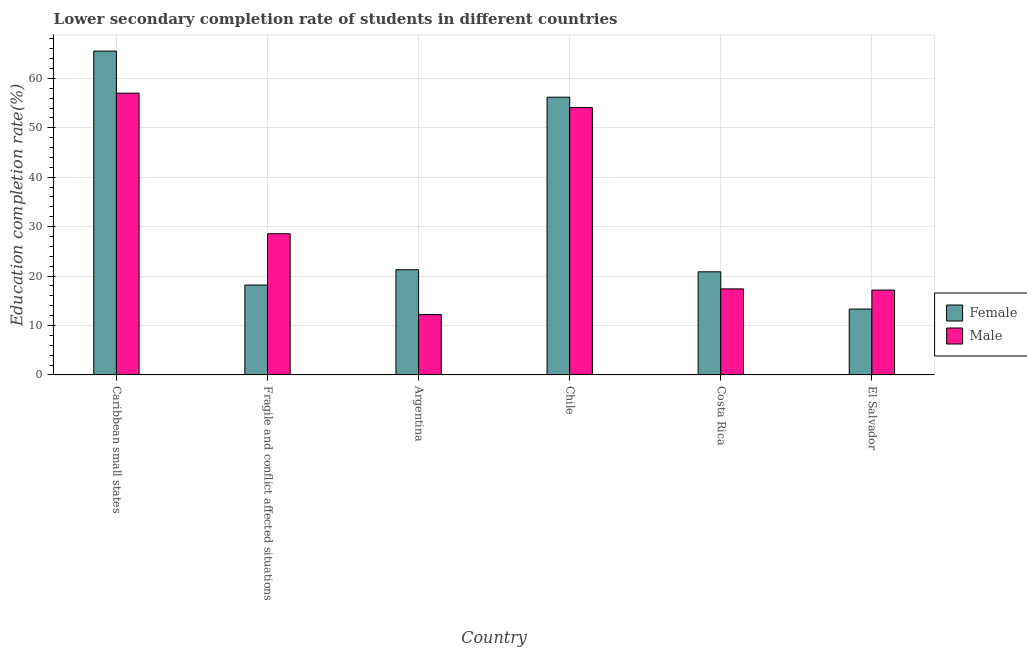How many different coloured bars are there?
Offer a very short reply. 2. Are the number of bars per tick equal to the number of legend labels?
Offer a very short reply. Yes. Are the number of bars on each tick of the X-axis equal?
Give a very brief answer. Yes. What is the label of the 6th group of bars from the left?
Offer a very short reply. El Salvador. In how many cases, is the number of bars for a given country not equal to the number of legend labels?
Offer a very short reply. 0. What is the education completion rate of female students in Argentina?
Ensure brevity in your answer.  21.28. Across all countries, what is the maximum education completion rate of male students?
Your response must be concise. 57. Across all countries, what is the minimum education completion rate of female students?
Make the answer very short. 13.32. In which country was the education completion rate of female students maximum?
Give a very brief answer. Caribbean small states. In which country was the education completion rate of male students minimum?
Your response must be concise. Argentina. What is the total education completion rate of female students in the graph?
Ensure brevity in your answer.  195.36. What is the difference between the education completion rate of female students in Argentina and that in Chile?
Your response must be concise. -34.91. What is the difference between the education completion rate of female students in Argentina and the education completion rate of male students in Caribbean small states?
Give a very brief answer. -35.72. What is the average education completion rate of male students per country?
Provide a succinct answer. 31.07. What is the difference between the education completion rate of female students and education completion rate of male students in Fragile and conflict affected situations?
Offer a very short reply. -10.38. In how many countries, is the education completion rate of male students greater than 58 %?
Make the answer very short. 0. What is the ratio of the education completion rate of female students in Chile to that in Costa Rica?
Ensure brevity in your answer.  2.69. What is the difference between the highest and the second highest education completion rate of male students?
Provide a succinct answer. 2.91. What is the difference between the highest and the lowest education completion rate of male students?
Your answer should be compact. 44.79. In how many countries, is the education completion rate of female students greater than the average education completion rate of female students taken over all countries?
Keep it short and to the point. 2. What does the 1st bar from the left in Chile represents?
Your answer should be compact. Female. How many bars are there?
Make the answer very short. 12. Does the graph contain grids?
Give a very brief answer. Yes. Where does the legend appear in the graph?
Give a very brief answer. Center right. How many legend labels are there?
Make the answer very short. 2. What is the title of the graph?
Offer a very short reply. Lower secondary completion rate of students in different countries. What is the label or title of the Y-axis?
Your answer should be very brief. Education completion rate(%). What is the Education completion rate(%) in Female in Caribbean small states?
Your answer should be compact. 65.52. What is the Education completion rate(%) of Male in Caribbean small states?
Keep it short and to the point. 57. What is the Education completion rate(%) of Female in Fragile and conflict affected situations?
Your answer should be compact. 18.18. What is the Education completion rate(%) in Male in Fragile and conflict affected situations?
Your response must be concise. 28.56. What is the Education completion rate(%) of Female in Argentina?
Provide a short and direct response. 21.28. What is the Education completion rate(%) in Male in Argentina?
Your answer should be very brief. 12.21. What is the Education completion rate(%) in Female in Chile?
Your answer should be very brief. 56.19. What is the Education completion rate(%) of Male in Chile?
Your answer should be compact. 54.09. What is the Education completion rate(%) in Female in Costa Rica?
Keep it short and to the point. 20.86. What is the Education completion rate(%) of Male in Costa Rica?
Keep it short and to the point. 17.41. What is the Education completion rate(%) of Female in El Salvador?
Keep it short and to the point. 13.32. What is the Education completion rate(%) of Male in El Salvador?
Make the answer very short. 17.16. Across all countries, what is the maximum Education completion rate(%) in Female?
Give a very brief answer. 65.52. Across all countries, what is the maximum Education completion rate(%) of Male?
Provide a short and direct response. 57. Across all countries, what is the minimum Education completion rate(%) of Female?
Your answer should be very brief. 13.32. Across all countries, what is the minimum Education completion rate(%) of Male?
Your response must be concise. 12.21. What is the total Education completion rate(%) of Female in the graph?
Ensure brevity in your answer.  195.36. What is the total Education completion rate(%) in Male in the graph?
Your response must be concise. 186.43. What is the difference between the Education completion rate(%) in Female in Caribbean small states and that in Fragile and conflict affected situations?
Your answer should be compact. 47.34. What is the difference between the Education completion rate(%) of Male in Caribbean small states and that in Fragile and conflict affected situations?
Your answer should be compact. 28.44. What is the difference between the Education completion rate(%) in Female in Caribbean small states and that in Argentina?
Your answer should be very brief. 44.24. What is the difference between the Education completion rate(%) in Male in Caribbean small states and that in Argentina?
Your answer should be very brief. 44.79. What is the difference between the Education completion rate(%) of Female in Caribbean small states and that in Chile?
Make the answer very short. 9.33. What is the difference between the Education completion rate(%) in Male in Caribbean small states and that in Chile?
Provide a short and direct response. 2.91. What is the difference between the Education completion rate(%) in Female in Caribbean small states and that in Costa Rica?
Provide a short and direct response. 44.66. What is the difference between the Education completion rate(%) in Male in Caribbean small states and that in Costa Rica?
Your answer should be compact. 39.59. What is the difference between the Education completion rate(%) of Female in Caribbean small states and that in El Salvador?
Offer a very short reply. 52.2. What is the difference between the Education completion rate(%) of Male in Caribbean small states and that in El Salvador?
Your response must be concise. 39.84. What is the difference between the Education completion rate(%) in Female in Fragile and conflict affected situations and that in Argentina?
Provide a short and direct response. -3.1. What is the difference between the Education completion rate(%) in Male in Fragile and conflict affected situations and that in Argentina?
Give a very brief answer. 16.35. What is the difference between the Education completion rate(%) of Female in Fragile and conflict affected situations and that in Chile?
Offer a very short reply. -38.01. What is the difference between the Education completion rate(%) in Male in Fragile and conflict affected situations and that in Chile?
Keep it short and to the point. -25.52. What is the difference between the Education completion rate(%) in Female in Fragile and conflict affected situations and that in Costa Rica?
Your answer should be compact. -2.68. What is the difference between the Education completion rate(%) in Male in Fragile and conflict affected situations and that in Costa Rica?
Your answer should be compact. 11.16. What is the difference between the Education completion rate(%) of Female in Fragile and conflict affected situations and that in El Salvador?
Your answer should be compact. 4.86. What is the difference between the Education completion rate(%) in Male in Fragile and conflict affected situations and that in El Salvador?
Offer a terse response. 11.4. What is the difference between the Education completion rate(%) of Female in Argentina and that in Chile?
Offer a very short reply. -34.91. What is the difference between the Education completion rate(%) of Male in Argentina and that in Chile?
Provide a short and direct response. -41.87. What is the difference between the Education completion rate(%) of Female in Argentina and that in Costa Rica?
Give a very brief answer. 0.42. What is the difference between the Education completion rate(%) in Male in Argentina and that in Costa Rica?
Your answer should be compact. -5.19. What is the difference between the Education completion rate(%) of Female in Argentina and that in El Salvador?
Offer a terse response. 7.95. What is the difference between the Education completion rate(%) in Male in Argentina and that in El Salvador?
Offer a very short reply. -4.95. What is the difference between the Education completion rate(%) of Female in Chile and that in Costa Rica?
Keep it short and to the point. 35.33. What is the difference between the Education completion rate(%) of Male in Chile and that in Costa Rica?
Ensure brevity in your answer.  36.68. What is the difference between the Education completion rate(%) in Female in Chile and that in El Salvador?
Offer a very short reply. 42.87. What is the difference between the Education completion rate(%) in Male in Chile and that in El Salvador?
Give a very brief answer. 36.93. What is the difference between the Education completion rate(%) of Female in Costa Rica and that in El Salvador?
Ensure brevity in your answer.  7.54. What is the difference between the Education completion rate(%) of Male in Costa Rica and that in El Salvador?
Make the answer very short. 0.24. What is the difference between the Education completion rate(%) in Female in Caribbean small states and the Education completion rate(%) in Male in Fragile and conflict affected situations?
Your response must be concise. 36.96. What is the difference between the Education completion rate(%) in Female in Caribbean small states and the Education completion rate(%) in Male in Argentina?
Keep it short and to the point. 53.31. What is the difference between the Education completion rate(%) in Female in Caribbean small states and the Education completion rate(%) in Male in Chile?
Offer a very short reply. 11.43. What is the difference between the Education completion rate(%) of Female in Caribbean small states and the Education completion rate(%) of Male in Costa Rica?
Your answer should be compact. 48.12. What is the difference between the Education completion rate(%) in Female in Caribbean small states and the Education completion rate(%) in Male in El Salvador?
Keep it short and to the point. 48.36. What is the difference between the Education completion rate(%) of Female in Fragile and conflict affected situations and the Education completion rate(%) of Male in Argentina?
Offer a very short reply. 5.97. What is the difference between the Education completion rate(%) of Female in Fragile and conflict affected situations and the Education completion rate(%) of Male in Chile?
Provide a succinct answer. -35.91. What is the difference between the Education completion rate(%) in Female in Fragile and conflict affected situations and the Education completion rate(%) in Male in Costa Rica?
Give a very brief answer. 0.77. What is the difference between the Education completion rate(%) in Female in Fragile and conflict affected situations and the Education completion rate(%) in Male in El Salvador?
Keep it short and to the point. 1.02. What is the difference between the Education completion rate(%) in Female in Argentina and the Education completion rate(%) in Male in Chile?
Give a very brief answer. -32.81. What is the difference between the Education completion rate(%) of Female in Argentina and the Education completion rate(%) of Male in Costa Rica?
Provide a succinct answer. 3.87. What is the difference between the Education completion rate(%) of Female in Argentina and the Education completion rate(%) of Male in El Salvador?
Offer a very short reply. 4.12. What is the difference between the Education completion rate(%) in Female in Chile and the Education completion rate(%) in Male in Costa Rica?
Give a very brief answer. 38.79. What is the difference between the Education completion rate(%) in Female in Chile and the Education completion rate(%) in Male in El Salvador?
Give a very brief answer. 39.03. What is the difference between the Education completion rate(%) in Female in Costa Rica and the Education completion rate(%) in Male in El Salvador?
Your response must be concise. 3.7. What is the average Education completion rate(%) of Female per country?
Your response must be concise. 32.56. What is the average Education completion rate(%) of Male per country?
Ensure brevity in your answer.  31.07. What is the difference between the Education completion rate(%) of Female and Education completion rate(%) of Male in Caribbean small states?
Make the answer very short. 8.52. What is the difference between the Education completion rate(%) in Female and Education completion rate(%) in Male in Fragile and conflict affected situations?
Provide a succinct answer. -10.38. What is the difference between the Education completion rate(%) in Female and Education completion rate(%) in Male in Argentina?
Your response must be concise. 9.07. What is the difference between the Education completion rate(%) of Female and Education completion rate(%) of Male in Chile?
Your response must be concise. 2.1. What is the difference between the Education completion rate(%) in Female and Education completion rate(%) in Male in Costa Rica?
Ensure brevity in your answer.  3.46. What is the difference between the Education completion rate(%) of Female and Education completion rate(%) of Male in El Salvador?
Your answer should be very brief. -3.84. What is the ratio of the Education completion rate(%) in Female in Caribbean small states to that in Fragile and conflict affected situations?
Ensure brevity in your answer.  3.6. What is the ratio of the Education completion rate(%) in Male in Caribbean small states to that in Fragile and conflict affected situations?
Provide a short and direct response. 2. What is the ratio of the Education completion rate(%) in Female in Caribbean small states to that in Argentina?
Your answer should be very brief. 3.08. What is the ratio of the Education completion rate(%) of Male in Caribbean small states to that in Argentina?
Provide a succinct answer. 4.67. What is the ratio of the Education completion rate(%) of Female in Caribbean small states to that in Chile?
Ensure brevity in your answer.  1.17. What is the ratio of the Education completion rate(%) in Male in Caribbean small states to that in Chile?
Offer a very short reply. 1.05. What is the ratio of the Education completion rate(%) of Female in Caribbean small states to that in Costa Rica?
Your response must be concise. 3.14. What is the ratio of the Education completion rate(%) of Male in Caribbean small states to that in Costa Rica?
Make the answer very short. 3.27. What is the ratio of the Education completion rate(%) in Female in Caribbean small states to that in El Salvador?
Provide a succinct answer. 4.92. What is the ratio of the Education completion rate(%) in Male in Caribbean small states to that in El Salvador?
Your answer should be compact. 3.32. What is the ratio of the Education completion rate(%) in Female in Fragile and conflict affected situations to that in Argentina?
Provide a short and direct response. 0.85. What is the ratio of the Education completion rate(%) in Male in Fragile and conflict affected situations to that in Argentina?
Give a very brief answer. 2.34. What is the ratio of the Education completion rate(%) in Female in Fragile and conflict affected situations to that in Chile?
Provide a succinct answer. 0.32. What is the ratio of the Education completion rate(%) in Male in Fragile and conflict affected situations to that in Chile?
Your answer should be very brief. 0.53. What is the ratio of the Education completion rate(%) of Female in Fragile and conflict affected situations to that in Costa Rica?
Provide a short and direct response. 0.87. What is the ratio of the Education completion rate(%) of Male in Fragile and conflict affected situations to that in Costa Rica?
Make the answer very short. 1.64. What is the ratio of the Education completion rate(%) of Female in Fragile and conflict affected situations to that in El Salvador?
Ensure brevity in your answer.  1.36. What is the ratio of the Education completion rate(%) of Male in Fragile and conflict affected situations to that in El Salvador?
Provide a short and direct response. 1.66. What is the ratio of the Education completion rate(%) in Female in Argentina to that in Chile?
Give a very brief answer. 0.38. What is the ratio of the Education completion rate(%) of Male in Argentina to that in Chile?
Make the answer very short. 0.23. What is the ratio of the Education completion rate(%) of Female in Argentina to that in Costa Rica?
Ensure brevity in your answer.  1.02. What is the ratio of the Education completion rate(%) of Male in Argentina to that in Costa Rica?
Your answer should be very brief. 0.7. What is the ratio of the Education completion rate(%) in Female in Argentina to that in El Salvador?
Your response must be concise. 1.6. What is the ratio of the Education completion rate(%) in Male in Argentina to that in El Salvador?
Keep it short and to the point. 0.71. What is the ratio of the Education completion rate(%) in Female in Chile to that in Costa Rica?
Offer a terse response. 2.69. What is the ratio of the Education completion rate(%) in Male in Chile to that in Costa Rica?
Provide a short and direct response. 3.11. What is the ratio of the Education completion rate(%) in Female in Chile to that in El Salvador?
Offer a very short reply. 4.22. What is the ratio of the Education completion rate(%) of Male in Chile to that in El Salvador?
Provide a succinct answer. 3.15. What is the ratio of the Education completion rate(%) in Female in Costa Rica to that in El Salvador?
Your answer should be compact. 1.57. What is the ratio of the Education completion rate(%) in Male in Costa Rica to that in El Salvador?
Give a very brief answer. 1.01. What is the difference between the highest and the second highest Education completion rate(%) in Female?
Ensure brevity in your answer.  9.33. What is the difference between the highest and the second highest Education completion rate(%) in Male?
Offer a very short reply. 2.91. What is the difference between the highest and the lowest Education completion rate(%) in Female?
Make the answer very short. 52.2. What is the difference between the highest and the lowest Education completion rate(%) in Male?
Offer a terse response. 44.79. 